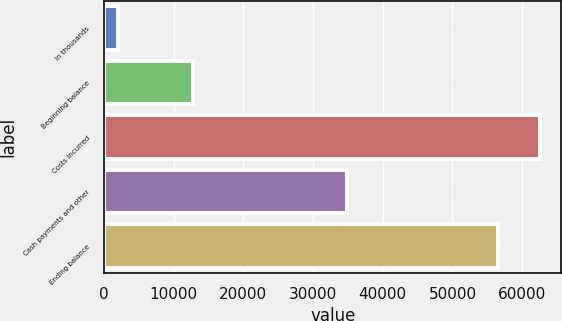Convert chart. <chart><loc_0><loc_0><loc_500><loc_500><bar_chart><fcel>In thousands<fcel>Beginning balance<fcel>Costs incurred<fcel>Cash payments and other<fcel>Ending balance<nl><fcel>2012<fcel>12805<fcel>62513.8<fcel>34868<fcel>56559<nl></chart> 